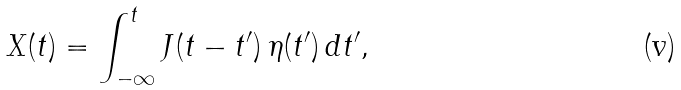<formula> <loc_0><loc_0><loc_500><loc_500>X ( t ) = \int _ { - \infty } ^ { t } J ( t - t ^ { \prime } ) \, \eta ( t ^ { \prime } ) \, d t ^ { \prime } ,</formula> 